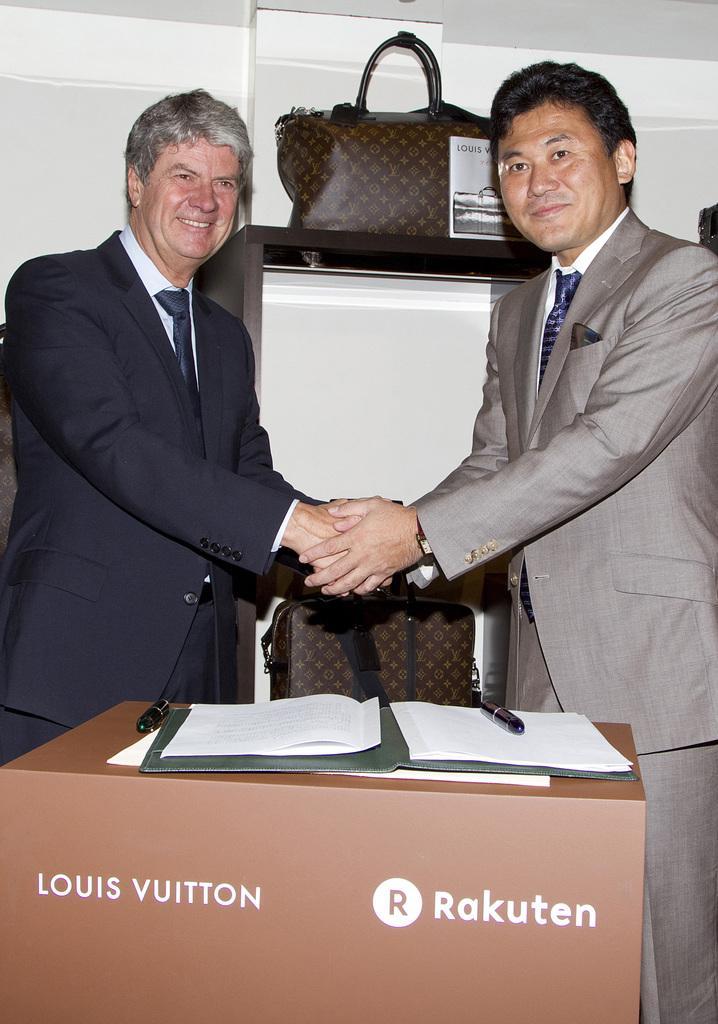Please provide a concise description of this image. In this image I can see two men are standing and giving shake hands. These men are smiling. Here I can see a table which has a book and some other objects on it. In the background I can see a bag, a white color wall and other objects. 